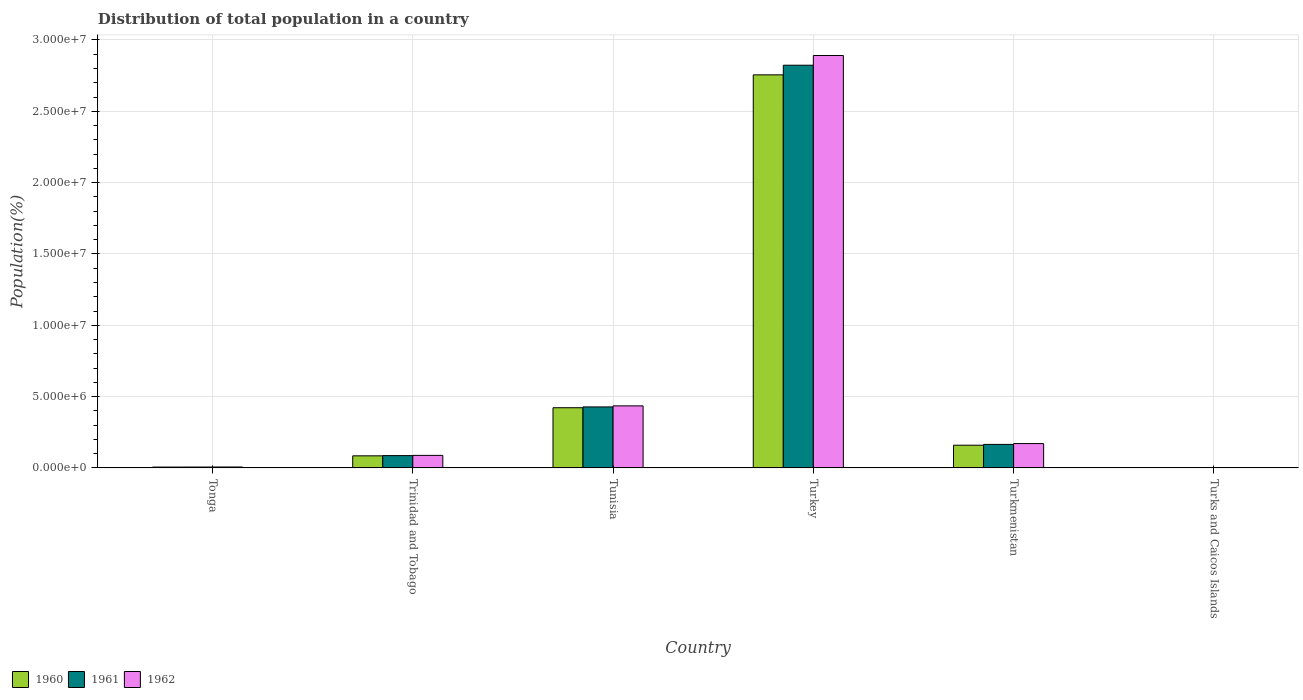How many different coloured bars are there?
Your response must be concise. 3. How many groups of bars are there?
Offer a very short reply. 6. Are the number of bars per tick equal to the number of legend labels?
Offer a terse response. Yes. How many bars are there on the 4th tick from the left?
Offer a very short reply. 3. How many bars are there on the 6th tick from the right?
Offer a terse response. 3. What is the label of the 1st group of bars from the left?
Offer a terse response. Tonga. In how many cases, is the number of bars for a given country not equal to the number of legend labels?
Offer a very short reply. 0. What is the population of in 1961 in Tunisia?
Your response must be concise. 4.28e+06. Across all countries, what is the maximum population of in 1962?
Your answer should be compact. 2.89e+07. Across all countries, what is the minimum population of in 1961?
Make the answer very short. 5760. In which country was the population of in 1962 minimum?
Offer a terse response. Turks and Caicos Islands. What is the total population of in 1962 in the graph?
Ensure brevity in your answer.  3.59e+07. What is the difference between the population of in 1962 in Trinidad and Tobago and that in Turkmenistan?
Keep it short and to the point. -8.29e+05. What is the difference between the population of in 1960 in Tonga and the population of in 1962 in Turkmenistan?
Give a very brief answer. -1.65e+06. What is the average population of in 1962 per country?
Your response must be concise. 5.99e+06. What is the difference between the population of of/in 1962 and population of of/in 1960 in Tonga?
Offer a very short reply. 4655. What is the ratio of the population of in 1961 in Tunisia to that in Turks and Caicos Islands?
Ensure brevity in your answer.  742.6. What is the difference between the highest and the second highest population of in 1960?
Ensure brevity in your answer.  2.33e+07. What is the difference between the highest and the lowest population of in 1960?
Provide a succinct answer. 2.75e+07. In how many countries, is the population of in 1961 greater than the average population of in 1961 taken over all countries?
Offer a terse response. 1. Is the sum of the population of in 1961 in Turkmenistan and Turks and Caicos Islands greater than the maximum population of in 1960 across all countries?
Make the answer very short. No. Are all the bars in the graph horizontal?
Offer a terse response. No. How many countries are there in the graph?
Your answer should be very brief. 6. Are the values on the major ticks of Y-axis written in scientific E-notation?
Provide a short and direct response. Yes. Does the graph contain grids?
Give a very brief answer. Yes. Where does the legend appear in the graph?
Provide a short and direct response. Bottom left. How many legend labels are there?
Give a very brief answer. 3. What is the title of the graph?
Provide a succinct answer. Distribution of total population in a country. What is the label or title of the Y-axis?
Your answer should be compact. Population(%). What is the Population(%) of 1960 in Tonga?
Offer a terse response. 6.16e+04. What is the Population(%) of 1961 in Tonga?
Offer a very short reply. 6.37e+04. What is the Population(%) of 1962 in Tonga?
Your response must be concise. 6.63e+04. What is the Population(%) in 1960 in Trinidad and Tobago?
Offer a very short reply. 8.48e+05. What is the Population(%) of 1961 in Trinidad and Tobago?
Provide a short and direct response. 8.65e+05. What is the Population(%) of 1962 in Trinidad and Tobago?
Give a very brief answer. 8.80e+05. What is the Population(%) in 1960 in Tunisia?
Offer a very short reply. 4.22e+06. What is the Population(%) in 1961 in Tunisia?
Your answer should be compact. 4.28e+06. What is the Population(%) of 1962 in Tunisia?
Ensure brevity in your answer.  4.35e+06. What is the Population(%) in 1960 in Turkey?
Your answer should be very brief. 2.76e+07. What is the Population(%) of 1961 in Turkey?
Provide a short and direct response. 2.82e+07. What is the Population(%) of 1962 in Turkey?
Offer a very short reply. 2.89e+07. What is the Population(%) of 1960 in Turkmenistan?
Offer a very short reply. 1.59e+06. What is the Population(%) of 1961 in Turkmenistan?
Provide a succinct answer. 1.65e+06. What is the Population(%) of 1962 in Turkmenistan?
Provide a short and direct response. 1.71e+06. What is the Population(%) of 1960 in Turks and Caicos Islands?
Provide a short and direct response. 5724. What is the Population(%) in 1961 in Turks and Caicos Islands?
Ensure brevity in your answer.  5760. What is the Population(%) in 1962 in Turks and Caicos Islands?
Make the answer very short. 5762. Across all countries, what is the maximum Population(%) of 1960?
Make the answer very short. 2.76e+07. Across all countries, what is the maximum Population(%) in 1961?
Make the answer very short. 2.82e+07. Across all countries, what is the maximum Population(%) of 1962?
Offer a terse response. 2.89e+07. Across all countries, what is the minimum Population(%) in 1960?
Provide a succinct answer. 5724. Across all countries, what is the minimum Population(%) of 1961?
Provide a succinct answer. 5760. Across all countries, what is the minimum Population(%) in 1962?
Your response must be concise. 5762. What is the total Population(%) in 1960 in the graph?
Keep it short and to the point. 3.43e+07. What is the total Population(%) of 1961 in the graph?
Your answer should be compact. 3.51e+07. What is the total Population(%) in 1962 in the graph?
Offer a very short reply. 3.59e+07. What is the difference between the Population(%) of 1960 in Tonga and that in Trinidad and Tobago?
Provide a succinct answer. -7.87e+05. What is the difference between the Population(%) of 1961 in Tonga and that in Trinidad and Tobago?
Ensure brevity in your answer.  -8.02e+05. What is the difference between the Population(%) in 1962 in Tonga and that in Trinidad and Tobago?
Your response must be concise. -8.14e+05. What is the difference between the Population(%) of 1960 in Tonga and that in Tunisia?
Your answer should be compact. -4.16e+06. What is the difference between the Population(%) of 1961 in Tonga and that in Tunisia?
Provide a short and direct response. -4.21e+06. What is the difference between the Population(%) in 1962 in Tonga and that in Tunisia?
Make the answer very short. -4.28e+06. What is the difference between the Population(%) in 1960 in Tonga and that in Turkey?
Make the answer very short. -2.75e+07. What is the difference between the Population(%) in 1961 in Tonga and that in Turkey?
Offer a terse response. -2.82e+07. What is the difference between the Population(%) in 1962 in Tonga and that in Turkey?
Ensure brevity in your answer.  -2.88e+07. What is the difference between the Population(%) of 1960 in Tonga and that in Turkmenistan?
Provide a short and direct response. -1.53e+06. What is the difference between the Population(%) of 1961 in Tonga and that in Turkmenistan?
Provide a short and direct response. -1.59e+06. What is the difference between the Population(%) of 1962 in Tonga and that in Turkmenistan?
Your answer should be very brief. -1.64e+06. What is the difference between the Population(%) in 1960 in Tonga and that in Turks and Caicos Islands?
Offer a terse response. 5.59e+04. What is the difference between the Population(%) of 1961 in Tonga and that in Turks and Caicos Islands?
Provide a short and direct response. 5.80e+04. What is the difference between the Population(%) in 1962 in Tonga and that in Turks and Caicos Islands?
Keep it short and to the point. 6.05e+04. What is the difference between the Population(%) in 1960 in Trinidad and Tobago and that in Tunisia?
Ensure brevity in your answer.  -3.37e+06. What is the difference between the Population(%) in 1961 in Trinidad and Tobago and that in Tunisia?
Offer a very short reply. -3.41e+06. What is the difference between the Population(%) of 1962 in Trinidad and Tobago and that in Tunisia?
Your response must be concise. -3.47e+06. What is the difference between the Population(%) of 1960 in Trinidad and Tobago and that in Turkey?
Provide a succinct answer. -2.67e+07. What is the difference between the Population(%) of 1961 in Trinidad and Tobago and that in Turkey?
Your answer should be very brief. -2.74e+07. What is the difference between the Population(%) in 1962 in Trinidad and Tobago and that in Turkey?
Your answer should be very brief. -2.80e+07. What is the difference between the Population(%) in 1960 in Trinidad and Tobago and that in Turkmenistan?
Keep it short and to the point. -7.45e+05. What is the difference between the Population(%) in 1961 in Trinidad and Tobago and that in Turkmenistan?
Make the answer very short. -7.85e+05. What is the difference between the Population(%) in 1962 in Trinidad and Tobago and that in Turkmenistan?
Offer a terse response. -8.29e+05. What is the difference between the Population(%) of 1960 in Trinidad and Tobago and that in Turks and Caicos Islands?
Your answer should be very brief. 8.43e+05. What is the difference between the Population(%) of 1961 in Trinidad and Tobago and that in Turks and Caicos Islands?
Your response must be concise. 8.60e+05. What is the difference between the Population(%) of 1962 in Trinidad and Tobago and that in Turks and Caicos Islands?
Your answer should be compact. 8.74e+05. What is the difference between the Population(%) in 1960 in Tunisia and that in Turkey?
Provide a succinct answer. -2.33e+07. What is the difference between the Population(%) in 1961 in Tunisia and that in Turkey?
Your response must be concise. -2.40e+07. What is the difference between the Population(%) of 1962 in Tunisia and that in Turkey?
Your response must be concise. -2.46e+07. What is the difference between the Population(%) of 1960 in Tunisia and that in Turkmenistan?
Make the answer very short. 2.63e+06. What is the difference between the Population(%) of 1961 in Tunisia and that in Turkmenistan?
Provide a short and direct response. 2.63e+06. What is the difference between the Population(%) of 1962 in Tunisia and that in Turkmenistan?
Make the answer very short. 2.64e+06. What is the difference between the Population(%) in 1960 in Tunisia and that in Turks and Caicos Islands?
Provide a short and direct response. 4.21e+06. What is the difference between the Population(%) of 1961 in Tunisia and that in Turks and Caicos Islands?
Your answer should be compact. 4.27e+06. What is the difference between the Population(%) in 1962 in Tunisia and that in Turks and Caicos Islands?
Keep it short and to the point. 4.35e+06. What is the difference between the Population(%) in 1960 in Turkey and that in Turkmenistan?
Offer a terse response. 2.60e+07. What is the difference between the Population(%) in 1961 in Turkey and that in Turkmenistan?
Provide a short and direct response. 2.66e+07. What is the difference between the Population(%) of 1962 in Turkey and that in Turkmenistan?
Give a very brief answer. 2.72e+07. What is the difference between the Population(%) of 1960 in Turkey and that in Turks and Caicos Islands?
Offer a terse response. 2.75e+07. What is the difference between the Population(%) of 1961 in Turkey and that in Turks and Caicos Islands?
Make the answer very short. 2.82e+07. What is the difference between the Population(%) of 1962 in Turkey and that in Turks and Caicos Islands?
Your answer should be compact. 2.89e+07. What is the difference between the Population(%) of 1960 in Turkmenistan and that in Turks and Caicos Islands?
Give a very brief answer. 1.59e+06. What is the difference between the Population(%) in 1961 in Turkmenistan and that in Turks and Caicos Islands?
Provide a short and direct response. 1.64e+06. What is the difference between the Population(%) of 1962 in Turkmenistan and that in Turks and Caicos Islands?
Your answer should be very brief. 1.70e+06. What is the difference between the Population(%) in 1960 in Tonga and the Population(%) in 1961 in Trinidad and Tobago?
Your response must be concise. -8.04e+05. What is the difference between the Population(%) of 1960 in Tonga and the Population(%) of 1962 in Trinidad and Tobago?
Your response must be concise. -8.18e+05. What is the difference between the Population(%) in 1961 in Tonga and the Population(%) in 1962 in Trinidad and Tobago?
Offer a very short reply. -8.16e+05. What is the difference between the Population(%) in 1960 in Tonga and the Population(%) in 1961 in Tunisia?
Your response must be concise. -4.22e+06. What is the difference between the Population(%) in 1960 in Tonga and the Population(%) in 1962 in Tunisia?
Give a very brief answer. -4.29e+06. What is the difference between the Population(%) of 1961 in Tonga and the Population(%) of 1962 in Tunisia?
Provide a succinct answer. -4.29e+06. What is the difference between the Population(%) of 1960 in Tonga and the Population(%) of 1961 in Turkey?
Keep it short and to the point. -2.82e+07. What is the difference between the Population(%) of 1960 in Tonga and the Population(%) of 1962 in Turkey?
Give a very brief answer. -2.88e+07. What is the difference between the Population(%) in 1961 in Tonga and the Population(%) in 1962 in Turkey?
Your answer should be compact. -2.88e+07. What is the difference between the Population(%) in 1960 in Tonga and the Population(%) in 1961 in Turkmenistan?
Give a very brief answer. -1.59e+06. What is the difference between the Population(%) of 1960 in Tonga and the Population(%) of 1962 in Turkmenistan?
Make the answer very short. -1.65e+06. What is the difference between the Population(%) in 1961 in Tonga and the Population(%) in 1962 in Turkmenistan?
Provide a short and direct response. -1.64e+06. What is the difference between the Population(%) in 1960 in Tonga and the Population(%) in 1961 in Turks and Caicos Islands?
Your answer should be very brief. 5.58e+04. What is the difference between the Population(%) in 1960 in Tonga and the Population(%) in 1962 in Turks and Caicos Islands?
Offer a very short reply. 5.58e+04. What is the difference between the Population(%) of 1961 in Tonga and the Population(%) of 1962 in Turks and Caicos Islands?
Offer a very short reply. 5.80e+04. What is the difference between the Population(%) of 1960 in Trinidad and Tobago and the Population(%) of 1961 in Tunisia?
Your answer should be compact. -3.43e+06. What is the difference between the Population(%) in 1960 in Trinidad and Tobago and the Population(%) in 1962 in Tunisia?
Offer a very short reply. -3.50e+06. What is the difference between the Population(%) of 1961 in Trinidad and Tobago and the Population(%) of 1962 in Tunisia?
Give a very brief answer. -3.49e+06. What is the difference between the Population(%) of 1960 in Trinidad and Tobago and the Population(%) of 1961 in Turkey?
Provide a succinct answer. -2.74e+07. What is the difference between the Population(%) in 1960 in Trinidad and Tobago and the Population(%) in 1962 in Turkey?
Offer a terse response. -2.81e+07. What is the difference between the Population(%) of 1961 in Trinidad and Tobago and the Population(%) of 1962 in Turkey?
Give a very brief answer. -2.80e+07. What is the difference between the Population(%) of 1960 in Trinidad and Tobago and the Population(%) of 1961 in Turkmenistan?
Keep it short and to the point. -8.01e+05. What is the difference between the Population(%) of 1960 in Trinidad and Tobago and the Population(%) of 1962 in Turkmenistan?
Provide a short and direct response. -8.60e+05. What is the difference between the Population(%) of 1961 in Trinidad and Tobago and the Population(%) of 1962 in Turkmenistan?
Make the answer very short. -8.43e+05. What is the difference between the Population(%) of 1960 in Trinidad and Tobago and the Population(%) of 1961 in Turks and Caicos Islands?
Give a very brief answer. 8.43e+05. What is the difference between the Population(%) of 1960 in Trinidad and Tobago and the Population(%) of 1962 in Turks and Caicos Islands?
Your answer should be compact. 8.43e+05. What is the difference between the Population(%) of 1961 in Trinidad and Tobago and the Population(%) of 1962 in Turks and Caicos Islands?
Offer a terse response. 8.60e+05. What is the difference between the Population(%) of 1960 in Tunisia and the Population(%) of 1961 in Turkey?
Make the answer very short. -2.40e+07. What is the difference between the Population(%) of 1960 in Tunisia and the Population(%) of 1962 in Turkey?
Make the answer very short. -2.47e+07. What is the difference between the Population(%) in 1961 in Tunisia and the Population(%) in 1962 in Turkey?
Your answer should be very brief. -2.46e+07. What is the difference between the Population(%) in 1960 in Tunisia and the Population(%) in 1961 in Turkmenistan?
Provide a succinct answer. 2.57e+06. What is the difference between the Population(%) in 1960 in Tunisia and the Population(%) in 1962 in Turkmenistan?
Provide a succinct answer. 2.51e+06. What is the difference between the Population(%) of 1961 in Tunisia and the Population(%) of 1962 in Turkmenistan?
Offer a terse response. 2.57e+06. What is the difference between the Population(%) in 1960 in Tunisia and the Population(%) in 1961 in Turks and Caicos Islands?
Give a very brief answer. 4.21e+06. What is the difference between the Population(%) of 1960 in Tunisia and the Population(%) of 1962 in Turks and Caicos Islands?
Your response must be concise. 4.21e+06. What is the difference between the Population(%) of 1961 in Tunisia and the Population(%) of 1962 in Turks and Caicos Islands?
Provide a short and direct response. 4.27e+06. What is the difference between the Population(%) of 1960 in Turkey and the Population(%) of 1961 in Turkmenistan?
Your response must be concise. 2.59e+07. What is the difference between the Population(%) in 1960 in Turkey and the Population(%) in 1962 in Turkmenistan?
Your response must be concise. 2.58e+07. What is the difference between the Population(%) of 1961 in Turkey and the Population(%) of 1962 in Turkmenistan?
Offer a terse response. 2.65e+07. What is the difference between the Population(%) of 1960 in Turkey and the Population(%) of 1961 in Turks and Caicos Islands?
Give a very brief answer. 2.75e+07. What is the difference between the Population(%) of 1960 in Turkey and the Population(%) of 1962 in Turks and Caicos Islands?
Your answer should be very brief. 2.75e+07. What is the difference between the Population(%) in 1961 in Turkey and the Population(%) in 1962 in Turks and Caicos Islands?
Your answer should be compact. 2.82e+07. What is the difference between the Population(%) of 1960 in Turkmenistan and the Population(%) of 1961 in Turks and Caicos Islands?
Give a very brief answer. 1.59e+06. What is the difference between the Population(%) of 1960 in Turkmenistan and the Population(%) of 1962 in Turks and Caicos Islands?
Give a very brief answer. 1.59e+06. What is the difference between the Population(%) in 1961 in Turkmenistan and the Population(%) in 1962 in Turks and Caicos Islands?
Offer a very short reply. 1.64e+06. What is the average Population(%) of 1960 per country?
Your answer should be compact. 5.71e+06. What is the average Population(%) of 1961 per country?
Your answer should be compact. 5.85e+06. What is the average Population(%) in 1962 per country?
Provide a short and direct response. 5.99e+06. What is the difference between the Population(%) in 1960 and Population(%) in 1961 in Tonga?
Your answer should be compact. -2140. What is the difference between the Population(%) in 1960 and Population(%) in 1962 in Tonga?
Offer a very short reply. -4655. What is the difference between the Population(%) of 1961 and Population(%) of 1962 in Tonga?
Your response must be concise. -2515. What is the difference between the Population(%) of 1960 and Population(%) of 1961 in Trinidad and Tobago?
Keep it short and to the point. -1.69e+04. What is the difference between the Population(%) in 1960 and Population(%) in 1962 in Trinidad and Tobago?
Provide a short and direct response. -3.15e+04. What is the difference between the Population(%) in 1961 and Population(%) in 1962 in Trinidad and Tobago?
Make the answer very short. -1.47e+04. What is the difference between the Population(%) in 1960 and Population(%) in 1961 in Tunisia?
Make the answer very short. -5.67e+04. What is the difference between the Population(%) in 1960 and Population(%) in 1962 in Tunisia?
Offer a terse response. -1.30e+05. What is the difference between the Population(%) of 1961 and Population(%) of 1962 in Tunisia?
Make the answer very short. -7.34e+04. What is the difference between the Population(%) of 1960 and Population(%) of 1961 in Turkey?
Give a very brief answer. -6.76e+05. What is the difference between the Population(%) in 1960 and Population(%) in 1962 in Turkey?
Make the answer very short. -1.36e+06. What is the difference between the Population(%) of 1961 and Population(%) of 1962 in Turkey?
Provide a succinct answer. -6.81e+05. What is the difference between the Population(%) of 1960 and Population(%) of 1961 in Turkmenistan?
Keep it short and to the point. -5.64e+04. What is the difference between the Population(%) in 1960 and Population(%) in 1962 in Turkmenistan?
Your answer should be compact. -1.15e+05. What is the difference between the Population(%) in 1961 and Population(%) in 1962 in Turkmenistan?
Your answer should be compact. -5.88e+04. What is the difference between the Population(%) of 1960 and Population(%) of 1961 in Turks and Caicos Islands?
Keep it short and to the point. -36. What is the difference between the Population(%) of 1960 and Population(%) of 1962 in Turks and Caicos Islands?
Your answer should be compact. -38. What is the difference between the Population(%) in 1961 and Population(%) in 1962 in Turks and Caicos Islands?
Your response must be concise. -2. What is the ratio of the Population(%) of 1960 in Tonga to that in Trinidad and Tobago?
Your answer should be compact. 0.07. What is the ratio of the Population(%) in 1961 in Tonga to that in Trinidad and Tobago?
Keep it short and to the point. 0.07. What is the ratio of the Population(%) of 1962 in Tonga to that in Trinidad and Tobago?
Ensure brevity in your answer.  0.08. What is the ratio of the Population(%) in 1960 in Tonga to that in Tunisia?
Ensure brevity in your answer.  0.01. What is the ratio of the Population(%) in 1961 in Tonga to that in Tunisia?
Offer a terse response. 0.01. What is the ratio of the Population(%) in 1962 in Tonga to that in Tunisia?
Offer a terse response. 0.02. What is the ratio of the Population(%) of 1960 in Tonga to that in Turkey?
Provide a succinct answer. 0. What is the ratio of the Population(%) of 1961 in Tonga to that in Turkey?
Your answer should be very brief. 0. What is the ratio of the Population(%) of 1962 in Tonga to that in Turkey?
Ensure brevity in your answer.  0. What is the ratio of the Population(%) in 1960 in Tonga to that in Turkmenistan?
Your answer should be very brief. 0.04. What is the ratio of the Population(%) in 1961 in Tonga to that in Turkmenistan?
Give a very brief answer. 0.04. What is the ratio of the Population(%) of 1962 in Tonga to that in Turkmenistan?
Keep it short and to the point. 0.04. What is the ratio of the Population(%) of 1960 in Tonga to that in Turks and Caicos Islands?
Make the answer very short. 10.76. What is the ratio of the Population(%) of 1961 in Tonga to that in Turks and Caicos Islands?
Provide a short and direct response. 11.07. What is the ratio of the Population(%) of 1962 in Tonga to that in Turks and Caicos Islands?
Your answer should be compact. 11.5. What is the ratio of the Population(%) of 1960 in Trinidad and Tobago to that in Tunisia?
Offer a very short reply. 0.2. What is the ratio of the Population(%) of 1961 in Trinidad and Tobago to that in Tunisia?
Offer a very short reply. 0.2. What is the ratio of the Population(%) in 1962 in Trinidad and Tobago to that in Tunisia?
Your answer should be compact. 0.2. What is the ratio of the Population(%) in 1960 in Trinidad and Tobago to that in Turkey?
Your response must be concise. 0.03. What is the ratio of the Population(%) of 1961 in Trinidad and Tobago to that in Turkey?
Keep it short and to the point. 0.03. What is the ratio of the Population(%) of 1962 in Trinidad and Tobago to that in Turkey?
Provide a short and direct response. 0.03. What is the ratio of the Population(%) of 1960 in Trinidad and Tobago to that in Turkmenistan?
Make the answer very short. 0.53. What is the ratio of the Population(%) in 1961 in Trinidad and Tobago to that in Turkmenistan?
Provide a short and direct response. 0.52. What is the ratio of the Population(%) in 1962 in Trinidad and Tobago to that in Turkmenistan?
Offer a very short reply. 0.52. What is the ratio of the Population(%) of 1960 in Trinidad and Tobago to that in Turks and Caicos Islands?
Your answer should be compact. 148.23. What is the ratio of the Population(%) in 1961 in Trinidad and Tobago to that in Turks and Caicos Islands?
Provide a short and direct response. 150.24. What is the ratio of the Population(%) of 1962 in Trinidad and Tobago to that in Turks and Caicos Islands?
Offer a very short reply. 152.73. What is the ratio of the Population(%) in 1960 in Tunisia to that in Turkey?
Your answer should be very brief. 0.15. What is the ratio of the Population(%) in 1961 in Tunisia to that in Turkey?
Your answer should be compact. 0.15. What is the ratio of the Population(%) in 1962 in Tunisia to that in Turkey?
Your answer should be very brief. 0.15. What is the ratio of the Population(%) of 1960 in Tunisia to that in Turkmenistan?
Keep it short and to the point. 2.65. What is the ratio of the Population(%) of 1961 in Tunisia to that in Turkmenistan?
Provide a short and direct response. 2.59. What is the ratio of the Population(%) in 1962 in Tunisia to that in Turkmenistan?
Offer a terse response. 2.55. What is the ratio of the Population(%) in 1960 in Tunisia to that in Turks and Caicos Islands?
Keep it short and to the point. 737.37. What is the ratio of the Population(%) of 1961 in Tunisia to that in Turks and Caicos Islands?
Ensure brevity in your answer.  742.6. What is the ratio of the Population(%) of 1962 in Tunisia to that in Turks and Caicos Islands?
Keep it short and to the point. 755.09. What is the ratio of the Population(%) in 1960 in Turkey to that in Turkmenistan?
Your answer should be compact. 17.29. What is the ratio of the Population(%) in 1961 in Turkey to that in Turkmenistan?
Offer a very short reply. 17.11. What is the ratio of the Population(%) in 1962 in Turkey to that in Turkmenistan?
Provide a short and direct response. 16.92. What is the ratio of the Population(%) in 1960 in Turkey to that in Turks and Caicos Islands?
Keep it short and to the point. 4813.64. What is the ratio of the Population(%) in 1961 in Turkey to that in Turks and Caicos Islands?
Make the answer very short. 4900.92. What is the ratio of the Population(%) of 1962 in Turkey to that in Turks and Caicos Islands?
Offer a terse response. 5017.35. What is the ratio of the Population(%) of 1960 in Turkmenistan to that in Turks and Caicos Islands?
Offer a terse response. 278.39. What is the ratio of the Population(%) of 1961 in Turkmenistan to that in Turks and Caicos Islands?
Offer a very short reply. 286.44. What is the ratio of the Population(%) in 1962 in Turkmenistan to that in Turks and Caicos Islands?
Keep it short and to the point. 296.55. What is the difference between the highest and the second highest Population(%) of 1960?
Offer a very short reply. 2.33e+07. What is the difference between the highest and the second highest Population(%) in 1961?
Give a very brief answer. 2.40e+07. What is the difference between the highest and the second highest Population(%) of 1962?
Your response must be concise. 2.46e+07. What is the difference between the highest and the lowest Population(%) in 1960?
Your answer should be compact. 2.75e+07. What is the difference between the highest and the lowest Population(%) of 1961?
Ensure brevity in your answer.  2.82e+07. What is the difference between the highest and the lowest Population(%) in 1962?
Keep it short and to the point. 2.89e+07. 